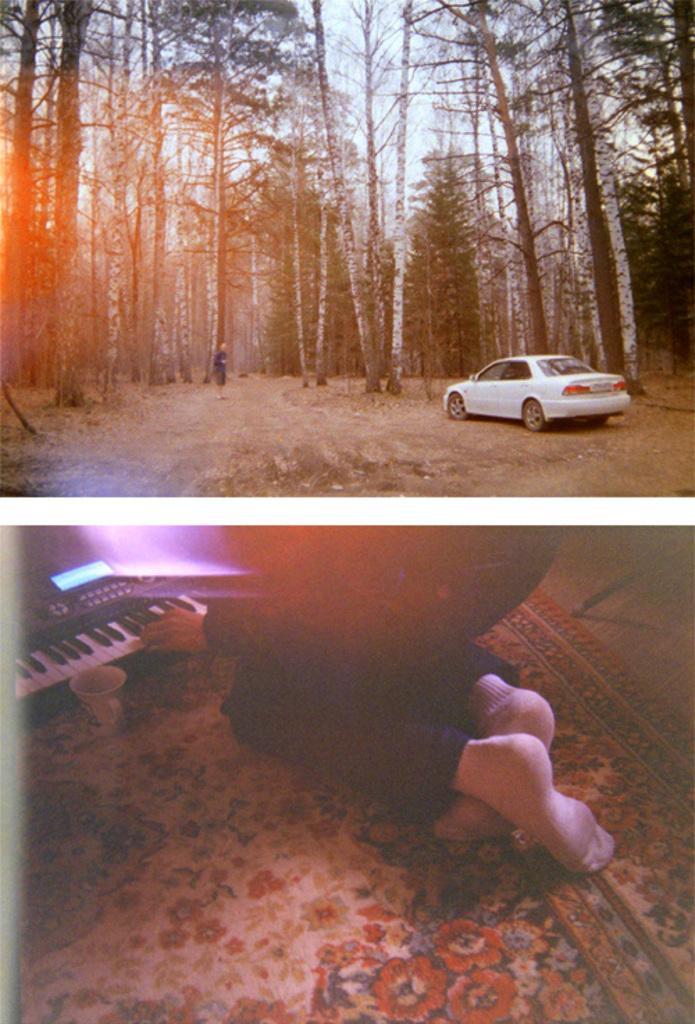Could you give a brief overview of what you see in this image? In this image there are two different images. At the top there is a car ,trees and sky. At the bottom there is a person , keyboard , cup and mat. 